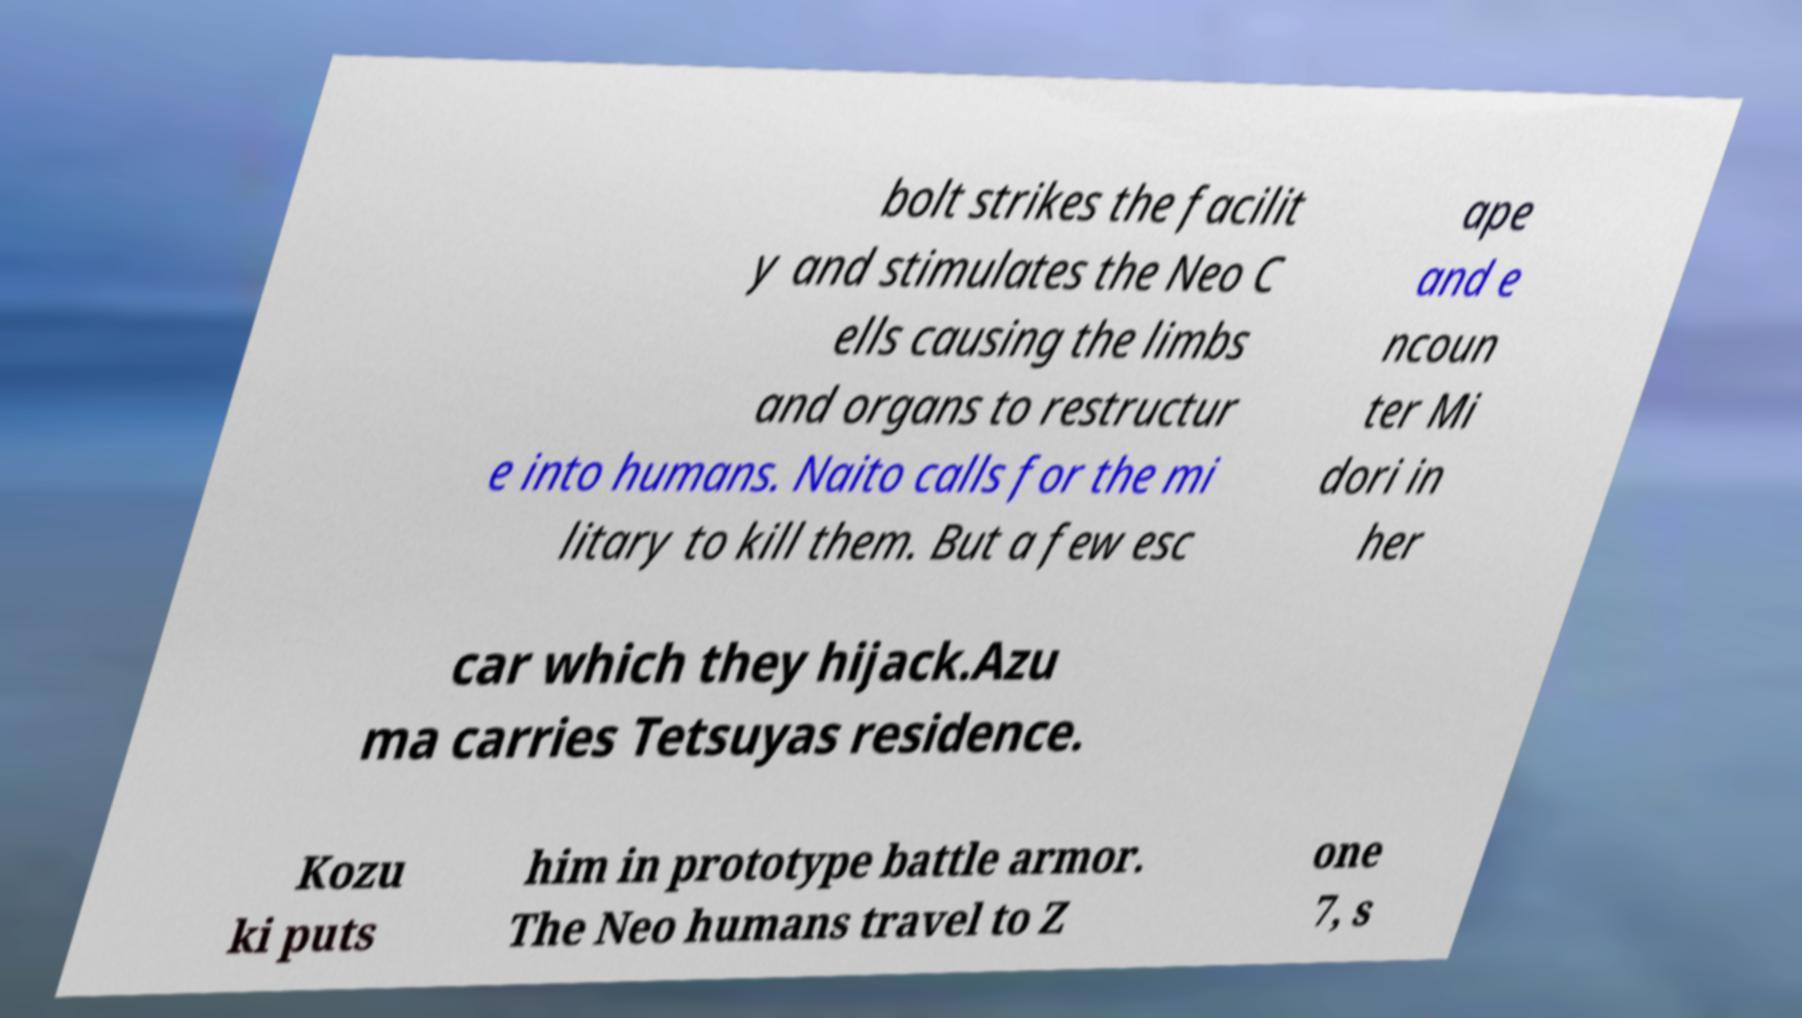Could you extract and type out the text from this image? bolt strikes the facilit y and stimulates the Neo C ells causing the limbs and organs to restructur e into humans. Naito calls for the mi litary to kill them. But a few esc ape and e ncoun ter Mi dori in her car which they hijack.Azu ma carries Tetsuyas residence. Kozu ki puts him in prototype battle armor. The Neo humans travel to Z one 7, s 